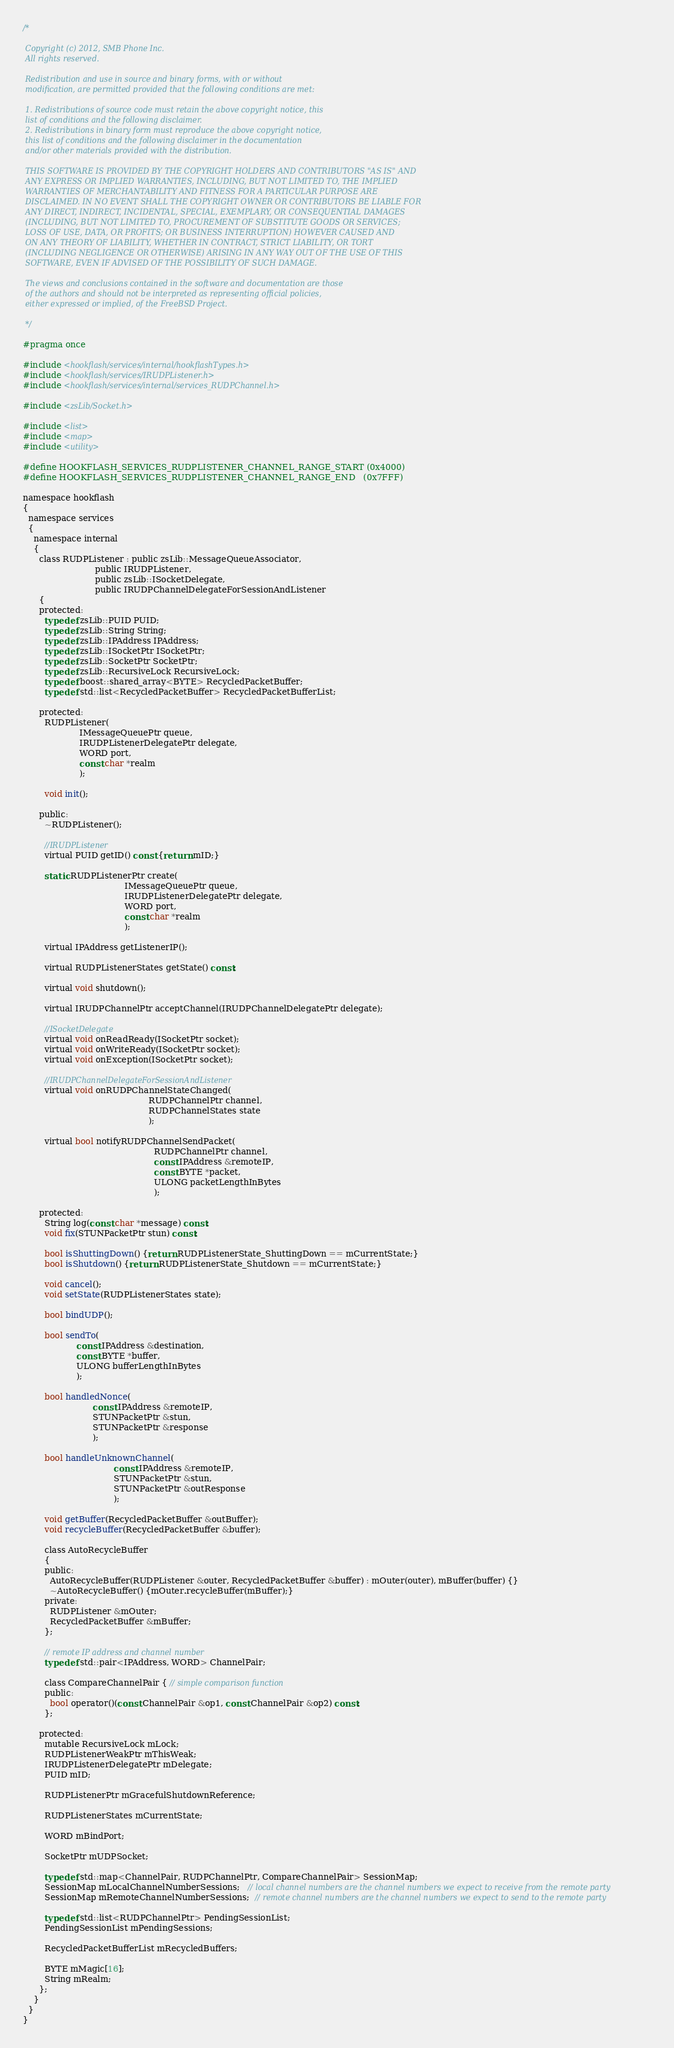<code> <loc_0><loc_0><loc_500><loc_500><_C_>/*
 
 Copyright (c) 2012, SMB Phone Inc.
 All rights reserved.
 
 Redistribution and use in source and binary forms, with or without
 modification, are permitted provided that the following conditions are met:
 
 1. Redistributions of source code must retain the above copyright notice, this
 list of conditions and the following disclaimer.
 2. Redistributions in binary form must reproduce the above copyright notice,
 this list of conditions and the following disclaimer in the documentation
 and/or other materials provided with the distribution.
 
 THIS SOFTWARE IS PROVIDED BY THE COPYRIGHT HOLDERS AND CONTRIBUTORS "AS IS" AND
 ANY EXPRESS OR IMPLIED WARRANTIES, INCLUDING, BUT NOT LIMITED TO, THE IMPLIED
 WARRANTIES OF MERCHANTABILITY AND FITNESS FOR A PARTICULAR PURPOSE ARE
 DISCLAIMED. IN NO EVENT SHALL THE COPYRIGHT OWNER OR CONTRIBUTORS BE LIABLE FOR
 ANY DIRECT, INDIRECT, INCIDENTAL, SPECIAL, EXEMPLARY, OR CONSEQUENTIAL DAMAGES
 (INCLUDING, BUT NOT LIMITED TO, PROCUREMENT OF SUBSTITUTE GOODS OR SERVICES;
 LOSS OF USE, DATA, OR PROFITS; OR BUSINESS INTERRUPTION) HOWEVER CAUSED AND
 ON ANY THEORY OF LIABILITY, WHETHER IN CONTRACT, STRICT LIABILITY, OR TORT
 (INCLUDING NEGLIGENCE OR OTHERWISE) ARISING IN ANY WAY OUT OF THE USE OF THIS
 SOFTWARE, EVEN IF ADVISED OF THE POSSIBILITY OF SUCH DAMAGE.
 
 The views and conclusions contained in the software and documentation are those
 of the authors and should not be interpreted as representing official policies,
 either expressed or implied, of the FreeBSD Project.
 
 */

#pragma once

#include <hookflash/services/internal/hookflashTypes.h>
#include <hookflash/services/IRUDPListener.h>
#include <hookflash/services/internal/services_RUDPChannel.h>

#include <zsLib/Socket.h>

#include <list>
#include <map>
#include <utility>

#define HOOKFLASH_SERVICES_RUDPLISTENER_CHANNEL_RANGE_START (0x4000)
#define HOOKFLASH_SERVICES_RUDPLISTENER_CHANNEL_RANGE_END   (0x7FFF)

namespace hookflash
{
  namespace services
  {
    namespace internal
    {
      class RUDPListener : public zsLib::MessageQueueAssociator,
                           public IRUDPListener,
                           public zsLib::ISocketDelegate,
                           public IRUDPChannelDelegateForSessionAndListener
      {
      protected:
        typedef zsLib::PUID PUID;
        typedef zsLib::String String;
        typedef zsLib::IPAddress IPAddress;
        typedef zsLib::ISocketPtr ISocketPtr;
        typedef zsLib::SocketPtr SocketPtr;
        typedef zsLib::RecursiveLock RecursiveLock;
        typedef boost::shared_array<BYTE> RecycledPacketBuffer;
        typedef std::list<RecycledPacketBuffer> RecycledPacketBufferList;

      protected:
        RUDPListener(
                     IMessageQueuePtr queue,
                     IRUDPListenerDelegatePtr delegate,
                     WORD port,
                     const char *realm
                     );

        void init();

      public:
        ~RUDPListener();

        //IRUDPListener
        virtual PUID getID() const {return mID;}

        static RUDPListenerPtr create(
                                      IMessageQueuePtr queue,
                                      IRUDPListenerDelegatePtr delegate,
                                      WORD port,
                                      const char *realm
                                      );

        virtual IPAddress getListenerIP();

        virtual RUDPListenerStates getState() const;

        virtual void shutdown();

        virtual IRUDPChannelPtr acceptChannel(IRUDPChannelDelegatePtr delegate);

        //ISocketDelegate
        virtual void onReadReady(ISocketPtr socket);
        virtual void onWriteReady(ISocketPtr socket);
        virtual void onException(ISocketPtr socket);

        //IRUDPChannelDelegateForSessionAndListener
        virtual void onRUDPChannelStateChanged(
                                               RUDPChannelPtr channel,
                                               RUDPChannelStates state
                                               );

        virtual bool notifyRUDPChannelSendPacket(
                                                 RUDPChannelPtr channel,
                                                 const IPAddress &remoteIP,
                                                 const BYTE *packet,
                                                 ULONG packetLengthInBytes
                                                 );

      protected:
        String log(const char *message) const;
        void fix(STUNPacketPtr stun) const;

        bool isShuttingDown() {return RUDPListenerState_ShuttingDown == mCurrentState;}
        bool isShutdown() {return RUDPListenerState_Shutdown == mCurrentState;}

        void cancel();
        void setState(RUDPListenerStates state);

        bool bindUDP();

        bool sendTo(
                    const IPAddress &destination,
                    const BYTE *buffer,
                    ULONG bufferLengthInBytes
                    );

        bool handledNonce(
                          const IPAddress &remoteIP,
                          STUNPacketPtr &stun,
                          STUNPacketPtr &response
                          );

        bool handleUnknownChannel(
                                  const IPAddress &remoteIP,
                                  STUNPacketPtr &stun,
                                  STUNPacketPtr &outResponse
                                  );

        void getBuffer(RecycledPacketBuffer &outBuffer);
        void recycleBuffer(RecycledPacketBuffer &buffer);

        class AutoRecycleBuffer
        {
        public:
          AutoRecycleBuffer(RUDPListener &outer, RecycledPacketBuffer &buffer) : mOuter(outer), mBuffer(buffer) {}
          ~AutoRecycleBuffer() {mOuter.recycleBuffer(mBuffer);}
        private:
          RUDPListener &mOuter;
          RecycledPacketBuffer &mBuffer;
        };

        // remote IP address and channel number
        typedef std::pair<IPAddress, WORD> ChannelPair;

        class CompareChannelPair { // simple comparison function
        public:
          bool operator()(const ChannelPair &op1, const ChannelPair &op2) const;
        };

      protected:
        mutable RecursiveLock mLock;
        RUDPListenerWeakPtr mThisWeak;
        IRUDPListenerDelegatePtr mDelegate;
        PUID mID;

        RUDPListenerPtr mGracefulShutdownReference;

        RUDPListenerStates mCurrentState;

        WORD mBindPort;

        SocketPtr mUDPSocket;

        typedef std::map<ChannelPair, RUDPChannelPtr, CompareChannelPair> SessionMap;
        SessionMap mLocalChannelNumberSessions;   // local channel numbers are the channel numbers we expect to receive from the remote party
        SessionMap mRemoteChannelNumberSessions;  // remote channel numbers are the channel numbers we expect to send to the remote party

        typedef std::list<RUDPChannelPtr> PendingSessionList;
        PendingSessionList mPendingSessions;

        RecycledPacketBufferList mRecycledBuffers;

        BYTE mMagic[16];
        String mRealm;
      };
    }
  }
}
</code> 